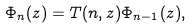Convert formula to latex. <formula><loc_0><loc_0><loc_500><loc_500>\Phi _ { n } ( z ) = T ( n , z ) \Phi _ { n - 1 } ( z ) ,</formula> 